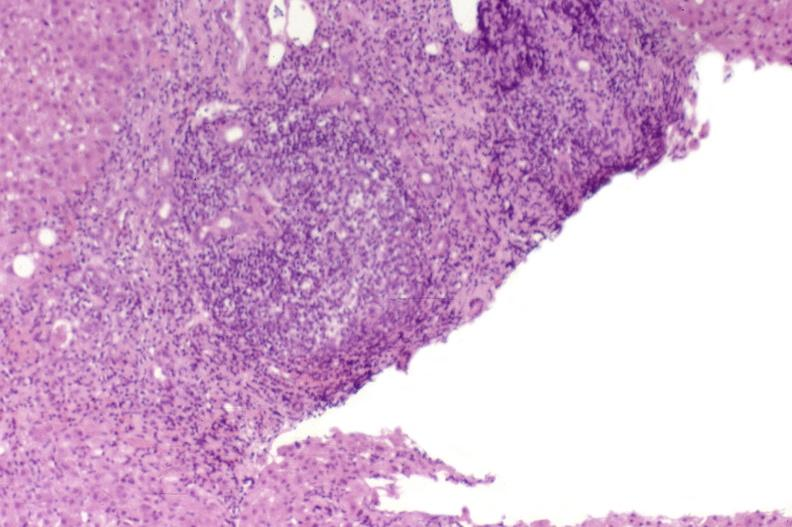does this image show recurrent hepatitis c virus?
Answer the question using a single word or phrase. Yes 